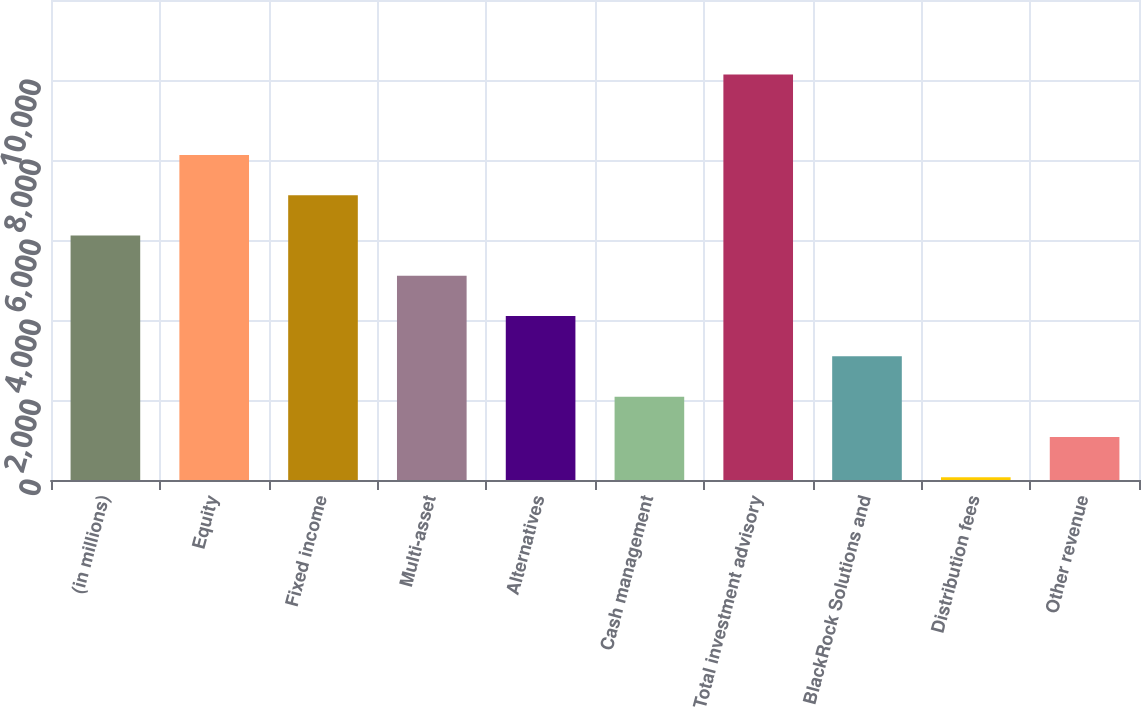Convert chart to OTSL. <chart><loc_0><loc_0><loc_500><loc_500><bar_chart><fcel>(in millions)<fcel>Equity<fcel>Fixed income<fcel>Multi-asset<fcel>Alternatives<fcel>Cash management<fcel>Total investment advisory<fcel>BlackRock Solutions and<fcel>Distribution fees<fcel>Other revenue<nl><fcel>6111.4<fcel>8125.2<fcel>7118.3<fcel>5104.5<fcel>4097.6<fcel>2083.8<fcel>10139<fcel>3090.7<fcel>70<fcel>1076.9<nl></chart> 